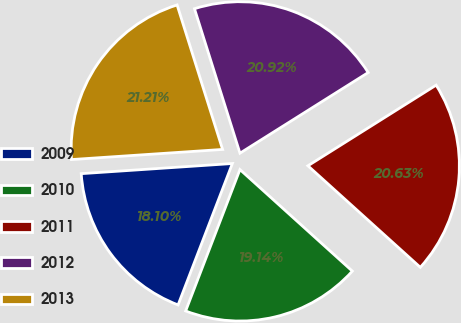Convert chart. <chart><loc_0><loc_0><loc_500><loc_500><pie_chart><fcel>2009<fcel>2010<fcel>2011<fcel>2012<fcel>2013<nl><fcel>18.1%<fcel>19.14%<fcel>20.63%<fcel>20.92%<fcel>21.21%<nl></chart> 